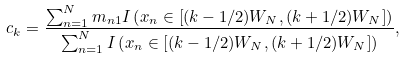Convert formula to latex. <formula><loc_0><loc_0><loc_500><loc_500>c _ { k } = \frac { \sum _ { n = 1 } ^ { N } m _ { n 1 } I \left ( x _ { n } \in \left [ ( k - 1 / 2 ) W _ { N } , ( k + 1 / 2 ) W _ { N } \right ] \right ) } { \sum _ { n = 1 } ^ { N } I \left ( x _ { n } \in \left [ ( k - 1 / 2 ) W _ { N } , ( k + 1 / 2 ) W _ { N } \right ] \right ) } ,</formula> 